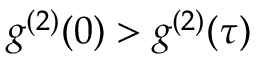Convert formula to latex. <formula><loc_0><loc_0><loc_500><loc_500>g ^ { ( 2 ) } ( 0 ) > g ^ { ( 2 ) } ( \tau )</formula> 